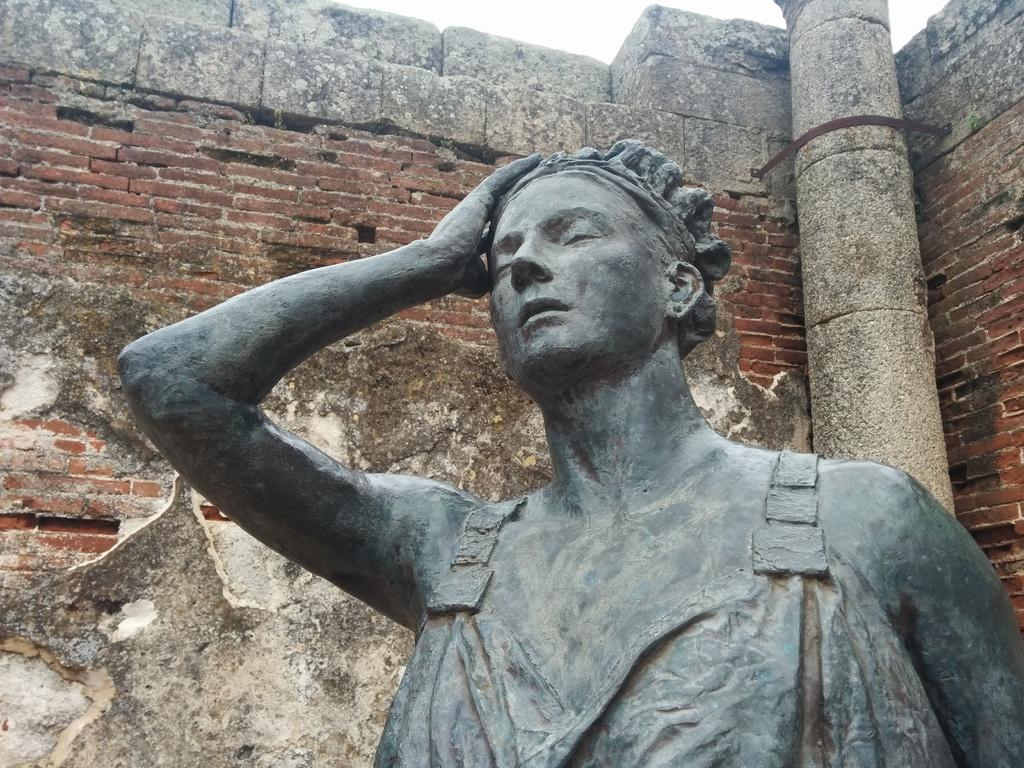What is the main subject in the picture? There is a statue in the picture. What can be seen in the backdrop of the image? There is a brick wall and a pillar in the backdrop. How would you describe the sky in the image? The sky is clear in the image. Can you tell me how many lamps are hanging from the pillar in the image? There are no lamps present in the image; the backdrop only includes a brick wall and a pillar. What type of car can be seen driving past the statue in the image? There is no car visible in the image; it only features a statue, a brick wall, and a pillar. 